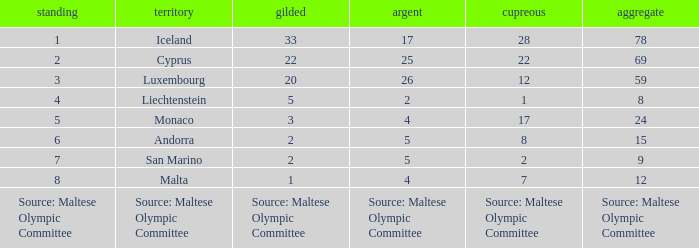What rank is the nation that has a bronze of source: Maltese Olympic Committee? Source: Maltese Olympic Committee. 